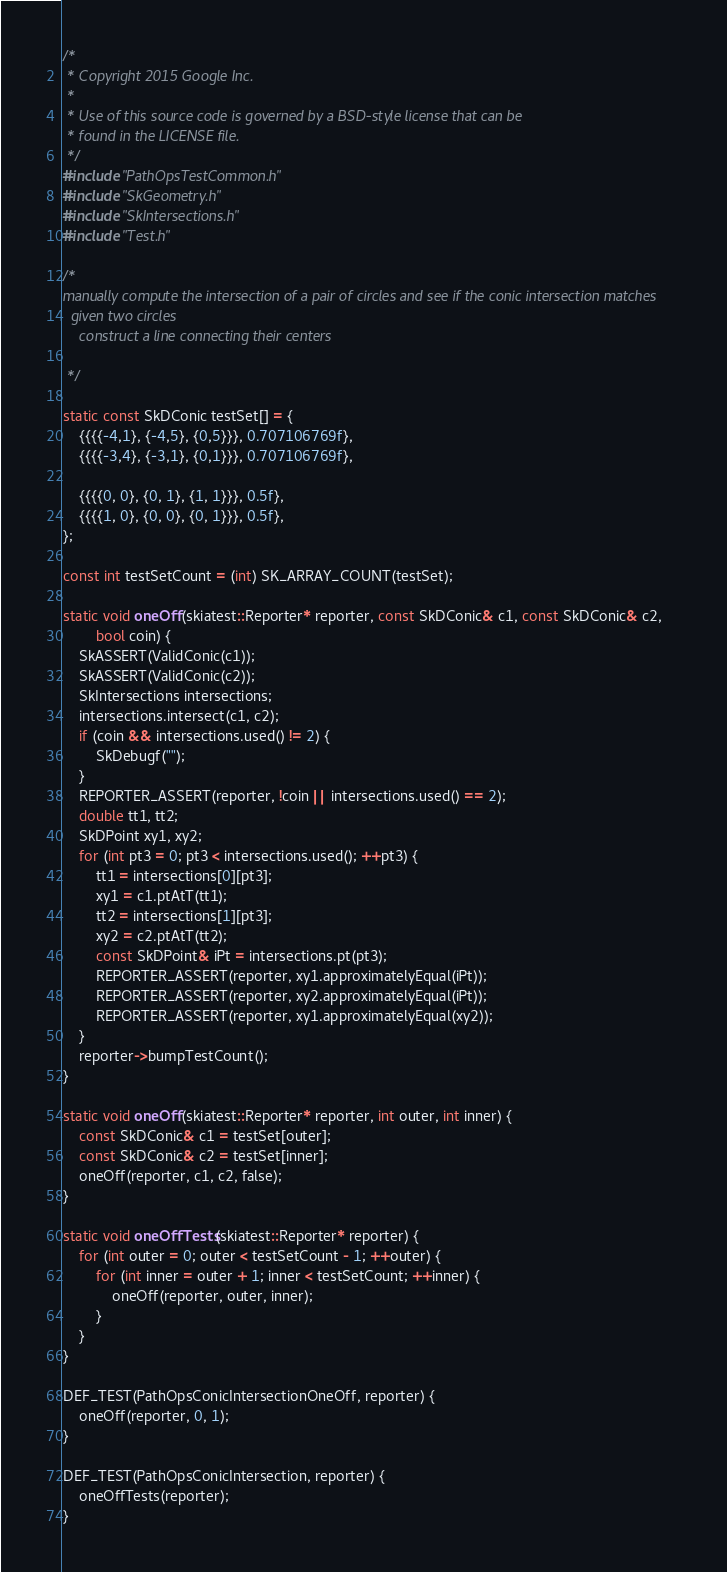<code> <loc_0><loc_0><loc_500><loc_500><_C++_>/*
 * Copyright 2015 Google Inc.
 *
 * Use of this source code is governed by a BSD-style license that can be
 * found in the LICENSE file.
 */
#include "PathOpsTestCommon.h"
#include "SkGeometry.h"
#include "SkIntersections.h"
#include "Test.h"

/*
manually compute the intersection of a pair of circles and see if the conic intersection matches
  given two circles
    construct a line connecting their centers
    
 */

static const SkDConic testSet[] = {
    {{{{-4,1}, {-4,5}, {0,5}}}, 0.707106769f},
    {{{{-3,4}, {-3,1}, {0,1}}}, 0.707106769f},

    {{{{0, 0}, {0, 1}, {1, 1}}}, 0.5f},
    {{{{1, 0}, {0, 0}, {0, 1}}}, 0.5f},
};

const int testSetCount = (int) SK_ARRAY_COUNT(testSet);

static void oneOff(skiatest::Reporter* reporter, const SkDConic& c1, const SkDConic& c2,
        bool coin) {
    SkASSERT(ValidConic(c1));
    SkASSERT(ValidConic(c2));
    SkIntersections intersections;
    intersections.intersect(c1, c2);
    if (coin && intersections.used() != 2) {
        SkDebugf("");
    }
    REPORTER_ASSERT(reporter, !coin || intersections.used() == 2);
    double tt1, tt2;
    SkDPoint xy1, xy2;
    for (int pt3 = 0; pt3 < intersections.used(); ++pt3) {
        tt1 = intersections[0][pt3];
        xy1 = c1.ptAtT(tt1);
        tt2 = intersections[1][pt3];
        xy2 = c2.ptAtT(tt2);
        const SkDPoint& iPt = intersections.pt(pt3);
        REPORTER_ASSERT(reporter, xy1.approximatelyEqual(iPt));
        REPORTER_ASSERT(reporter, xy2.approximatelyEqual(iPt));
        REPORTER_ASSERT(reporter, xy1.approximatelyEqual(xy2));
    }
    reporter->bumpTestCount();
}

static void oneOff(skiatest::Reporter* reporter, int outer, int inner) {
    const SkDConic& c1 = testSet[outer];
    const SkDConic& c2 = testSet[inner];
    oneOff(reporter, c1, c2, false);
}

static void oneOffTests(skiatest::Reporter* reporter) {
    for (int outer = 0; outer < testSetCount - 1; ++outer) {
        for (int inner = outer + 1; inner < testSetCount; ++inner) {
            oneOff(reporter, outer, inner);
        }
    }
}

DEF_TEST(PathOpsConicIntersectionOneOff, reporter) {
    oneOff(reporter, 0, 1);
}

DEF_TEST(PathOpsConicIntersection, reporter) {
    oneOffTests(reporter);
}
</code> 